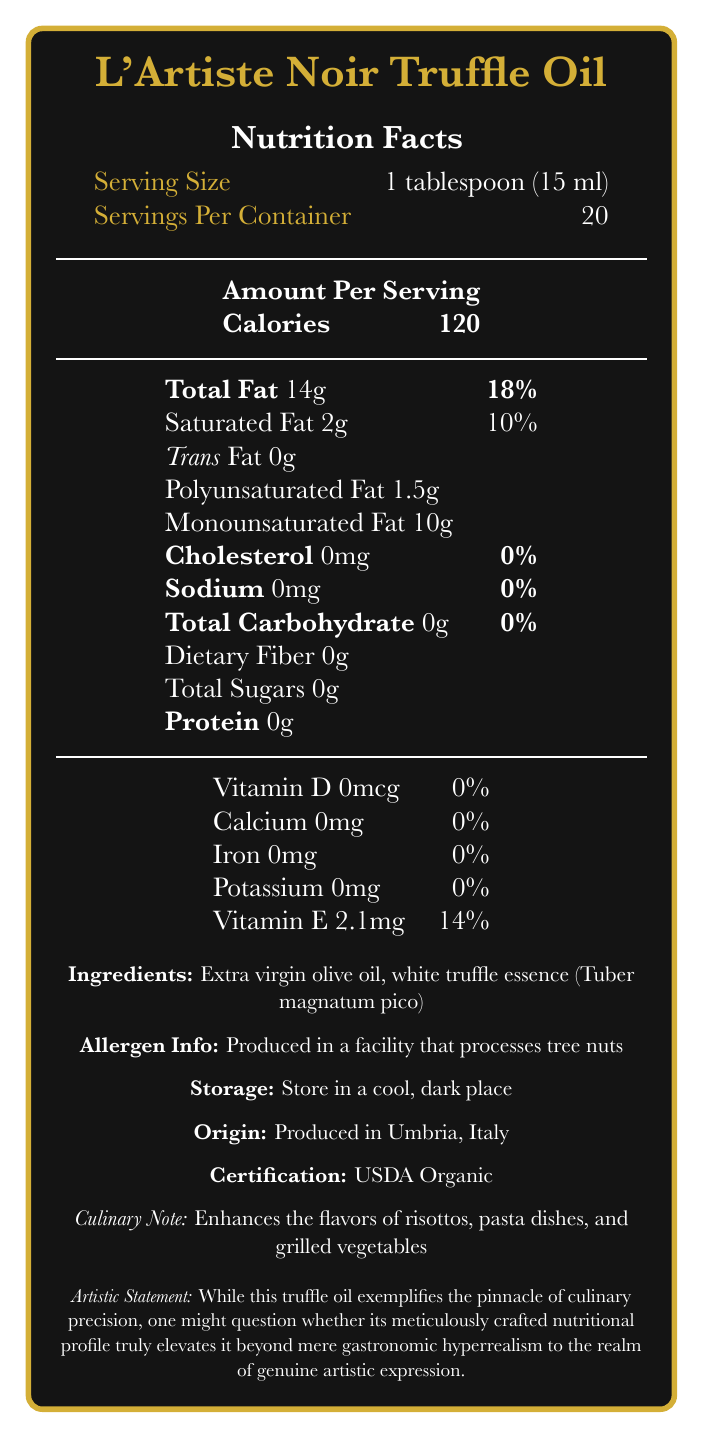what is the serving size of L'Artiste Noir Truffle Oil? The serving size is indicated in the nutrition facts section as 1 tablespoon (15 ml).
Answer: 1 tablespoon (15 ml) how many calories are in a single serving? The calories per serving are directly listed as 120 in the nutrition facts.
Answer: 120 what is the total fat content in one serving? The document states that each serving contains 14 grams of total fat.
Answer: 14g how much of the daily value of saturated fat does one serving provide? The saturated fat daily value percentage is given as 10% for a single serving.
Answer: 10% what is the amount of vitamin E per serving and its daily value percentage? The document specifies that it contains 2.1 mg of vitamin E, which is 14% of the daily value.
Answer: 2.1mg, 14% what fats are listed besides total and saturated fat, and what are their amounts? The document details polyunsaturated fat as 1.5g and monounsaturated fat as 10g per serving.
Answer: Polyunsaturated Fat 1.5g, Monounsaturated Fat 10g where is L'Artiste Noir Truffle Oil produced? The place of origin mentioned in the document is Umbria, Italy.
Answer: Umbria, Italy what certification does the truffle oil have? A. USDA Organic B. Non-GMO Project Verified C. Fair Trade Certified D. Certified Vegan The document mentions that the truffle oil is certified USDA Organic.
Answer: A. USDA Organic which of the following is true about the sodium content in L'Artiste Noir Truffle Oil? A. It is high in sodium B. It contains a moderate amount of sodium C. It is sodium-free D. The sodium content is not listed The document lists sodium content as 0mg, indicating it is sodium-free.
Answer: C. It is sodium-free does the document provide any dietary fiber content per serving? The document specifies 0g of dietary fiber content per serving.
Answer: No is this truffle oil suitable for people with tree nut allergies? Despite not containing tree nuts, it is produced in a facility that processes tree nuts, which can pose a risk for cross-contamination.
Answer: No describe the main nutritional components of L'Artiste Noir Truffle Oil. The key nutritional attributes presented show a high-fat content and calorie count with no other macronutrients and a notable amount of Vitamin E.
Answer: L'Artiste Noir Truffle Oil is primarily composed of fats, specifically 14g total fat per serving including 2g saturated fat. It provides 120 calories and contains no carbohydrates, protein, cholesterol, or sodium. It also offers 2.1mg of Vitamin E. how many servings are contained in one bottle of L'Artiste Noir Truffle Oil? The document provides that a container consists of 20 servings.
Answer: 20 can the artistic merit of L'Artiste Noir Truffle Oil's nutritional profile be considered beyond culinary precision? The document includes an artistic statement that questions whether the product's nutritional profile transcends mere precision to achieve artistic expression, but does not provide a definitive answer or criteria.
Answer: Not enough information 